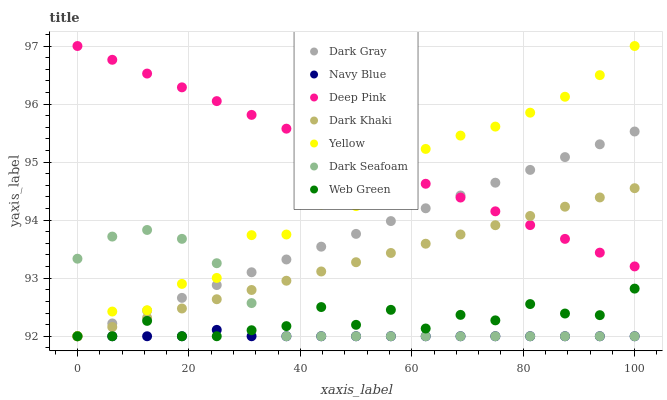Does Navy Blue have the minimum area under the curve?
Answer yes or no. Yes. Does Deep Pink have the maximum area under the curve?
Answer yes or no. Yes. Does Deep Pink have the minimum area under the curve?
Answer yes or no. No. Does Navy Blue have the maximum area under the curve?
Answer yes or no. No. Is Dark Gray the smoothest?
Answer yes or no. Yes. Is Web Green the roughest?
Answer yes or no. Yes. Is Deep Pink the smoothest?
Answer yes or no. No. Is Deep Pink the roughest?
Answer yes or no. No. Does Dark Khaki have the lowest value?
Answer yes or no. Yes. Does Deep Pink have the lowest value?
Answer yes or no. No. Does Yellow have the highest value?
Answer yes or no. Yes. Does Navy Blue have the highest value?
Answer yes or no. No. Is Dark Seafoam less than Deep Pink?
Answer yes or no. Yes. Is Deep Pink greater than Dark Seafoam?
Answer yes or no. Yes. Does Deep Pink intersect Yellow?
Answer yes or no. Yes. Is Deep Pink less than Yellow?
Answer yes or no. No. Is Deep Pink greater than Yellow?
Answer yes or no. No. Does Dark Seafoam intersect Deep Pink?
Answer yes or no. No. 